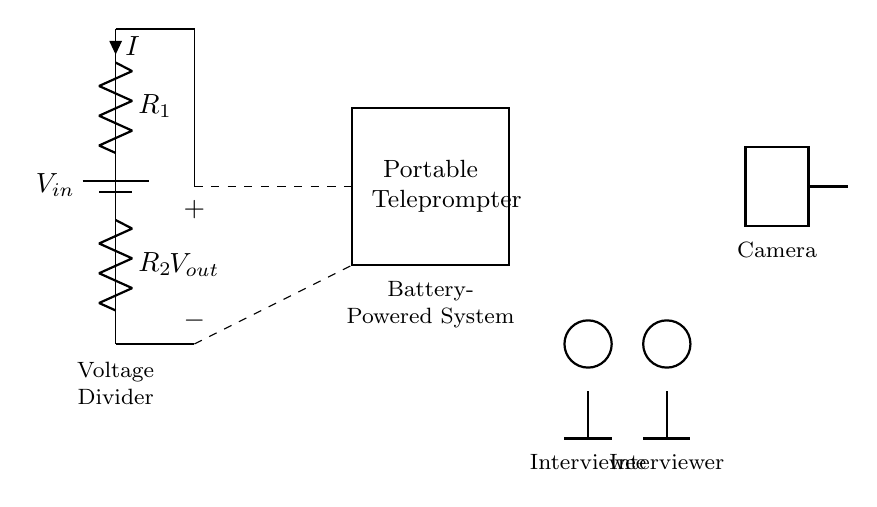What is the input voltage of the circuit? The input voltage is labeled as V_in at the top of the diagram, which is directly associated with the battery symbol.
Answer: V_in What are the values of the resistors in the voltage divider? The resistors are labeled R_1 and R_2, but their specific numerical values are not provided in the circuit diagram.
Answer: R_1 and R_2 What is the relationship between V_out and V_in? V_out is derived from the input voltage V_in based on the voltage divider rule, specifically V_out = V_in * (R_2 / (R_1 + R_2)). The output voltage depends on the resistor values.
Answer: V_out = V_in * (R_2 / (R_1 + R_2)) How does the voltage divider affect the teleprompter? The voltage divider ensures the teleprompter receives a lower and appropriate voltage output (V_out) for its operation, as shown by the dashed line connecting V_out to the teleprompter symbol.
Answer: Provides appropriate voltage What is the total current flowing through the circuit? The total current I in the circuit can be defined by Ohm’s law as I = V_in / (R_1 + R_2), where V_in is the supply voltage and R_1 and R_2 are the resistances.
Answer: I = V_in / (R_1 + R_2) What components make up the voltage divider? The voltage divider consists of two resistors (R_1 and R_2) in series connected to a battery (V_in), which creates a potential divide for the output voltage.
Answer: Two resistors and a battery What function does the dashed line serve in the circuit? The dashed line represents the connections of V_out to the teleprompter. It illustrates that the output voltage is supplied to the teleprompter system.
Answer: Connection to teleprompter 